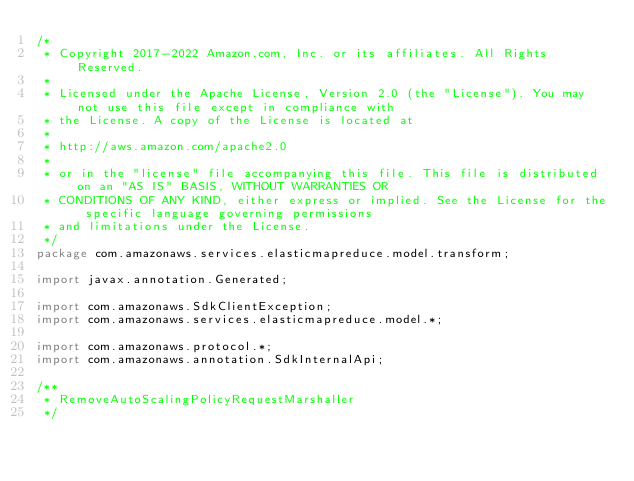<code> <loc_0><loc_0><loc_500><loc_500><_Java_>/*
 * Copyright 2017-2022 Amazon.com, Inc. or its affiliates. All Rights Reserved.
 * 
 * Licensed under the Apache License, Version 2.0 (the "License"). You may not use this file except in compliance with
 * the License. A copy of the License is located at
 * 
 * http://aws.amazon.com/apache2.0
 * 
 * or in the "license" file accompanying this file. This file is distributed on an "AS IS" BASIS, WITHOUT WARRANTIES OR
 * CONDITIONS OF ANY KIND, either express or implied. See the License for the specific language governing permissions
 * and limitations under the License.
 */
package com.amazonaws.services.elasticmapreduce.model.transform;

import javax.annotation.Generated;

import com.amazonaws.SdkClientException;
import com.amazonaws.services.elasticmapreduce.model.*;

import com.amazonaws.protocol.*;
import com.amazonaws.annotation.SdkInternalApi;

/**
 * RemoveAutoScalingPolicyRequestMarshaller
 */</code> 